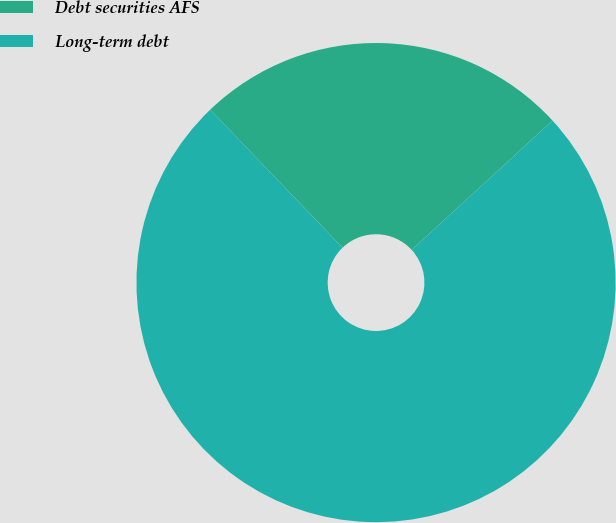<chart> <loc_0><loc_0><loc_500><loc_500><pie_chart><fcel>Debt securities AFS<fcel>Long-term debt<nl><fcel>25.34%<fcel>74.66%<nl></chart> 